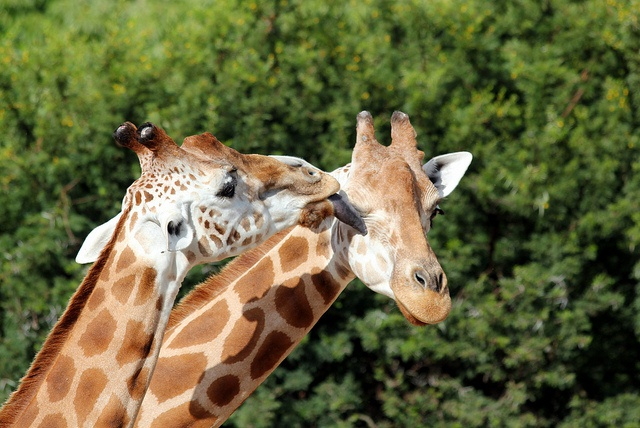Describe the objects in this image and their specific colors. I can see giraffe in olive, tan, ivory, and gray tones and giraffe in olive, ivory, tan, and gray tones in this image. 